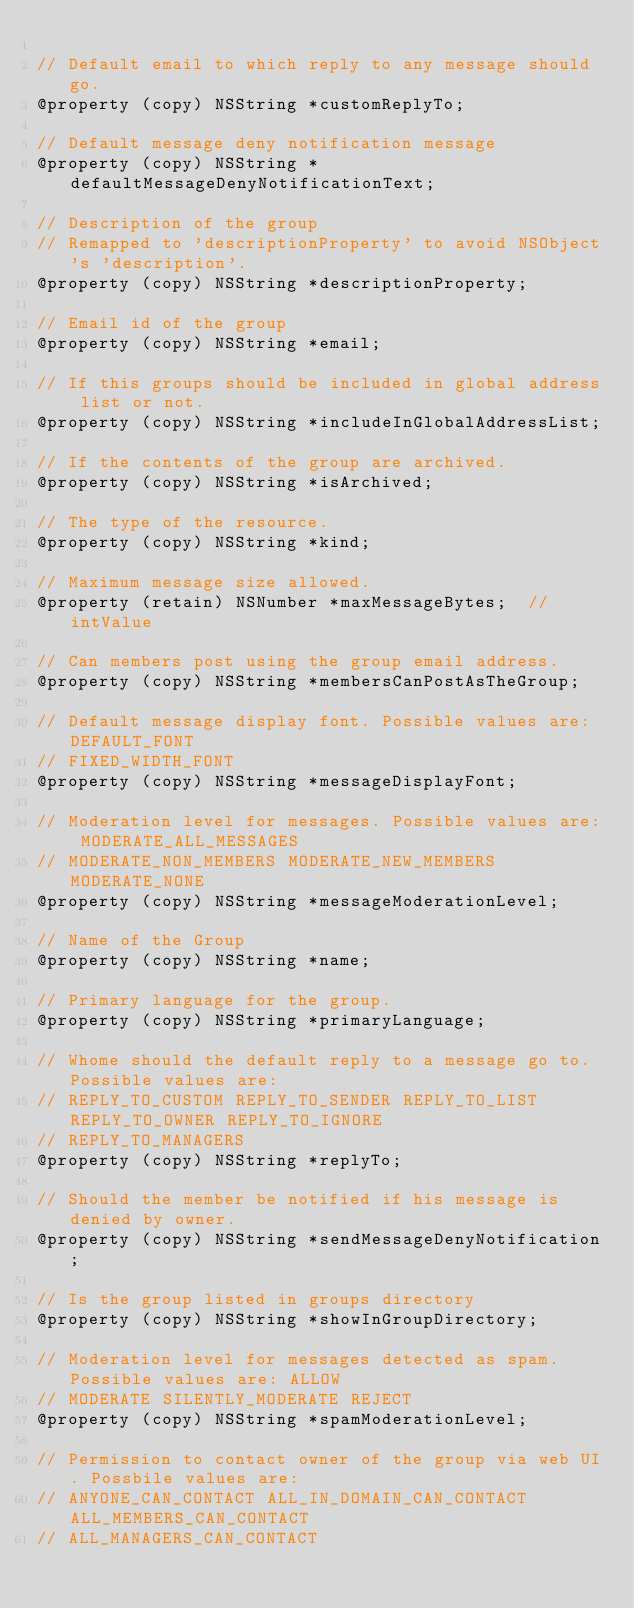<code> <loc_0><loc_0><loc_500><loc_500><_C_>
// Default email to which reply to any message should go.
@property (copy) NSString *customReplyTo;

// Default message deny notification message
@property (copy) NSString *defaultMessageDenyNotificationText;

// Description of the group
// Remapped to 'descriptionProperty' to avoid NSObject's 'description'.
@property (copy) NSString *descriptionProperty;

// Email id of the group
@property (copy) NSString *email;

// If this groups should be included in global address list or not.
@property (copy) NSString *includeInGlobalAddressList;

// If the contents of the group are archived.
@property (copy) NSString *isArchived;

// The type of the resource.
@property (copy) NSString *kind;

// Maximum message size allowed.
@property (retain) NSNumber *maxMessageBytes;  // intValue

// Can members post using the group email address.
@property (copy) NSString *membersCanPostAsTheGroup;

// Default message display font. Possible values are: DEFAULT_FONT
// FIXED_WIDTH_FONT
@property (copy) NSString *messageDisplayFont;

// Moderation level for messages. Possible values are: MODERATE_ALL_MESSAGES
// MODERATE_NON_MEMBERS MODERATE_NEW_MEMBERS MODERATE_NONE
@property (copy) NSString *messageModerationLevel;

// Name of the Group
@property (copy) NSString *name;

// Primary language for the group.
@property (copy) NSString *primaryLanguage;

// Whome should the default reply to a message go to. Possible values are:
// REPLY_TO_CUSTOM REPLY_TO_SENDER REPLY_TO_LIST REPLY_TO_OWNER REPLY_TO_IGNORE
// REPLY_TO_MANAGERS
@property (copy) NSString *replyTo;

// Should the member be notified if his message is denied by owner.
@property (copy) NSString *sendMessageDenyNotification;

// Is the group listed in groups directory
@property (copy) NSString *showInGroupDirectory;

// Moderation level for messages detected as spam. Possible values are: ALLOW
// MODERATE SILENTLY_MODERATE REJECT
@property (copy) NSString *spamModerationLevel;

// Permission to contact owner of the group via web UI. Possbile values are:
// ANYONE_CAN_CONTACT ALL_IN_DOMAIN_CAN_CONTACT ALL_MEMBERS_CAN_CONTACT
// ALL_MANAGERS_CAN_CONTACT</code> 